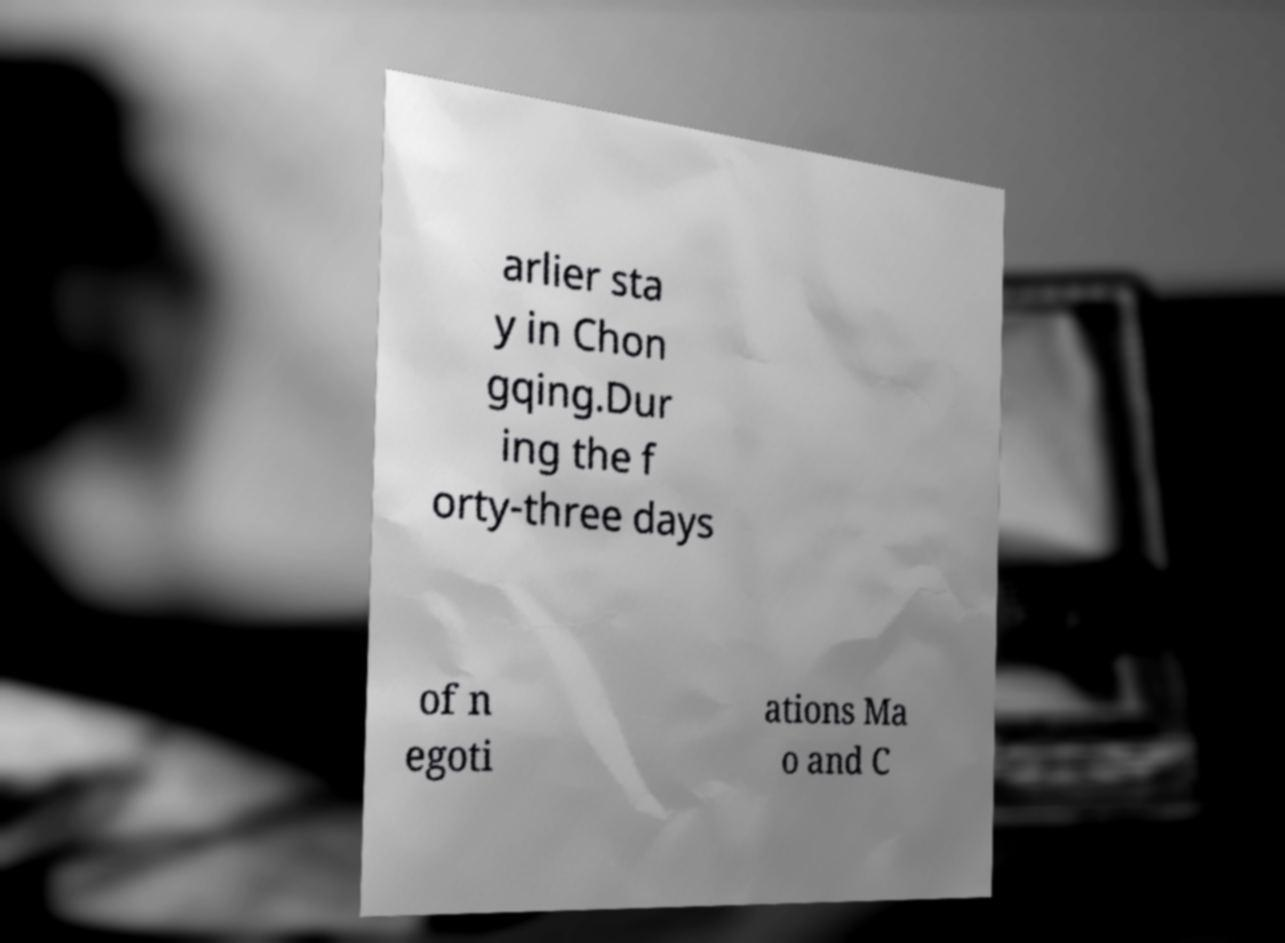Please read and relay the text visible in this image. What does it say? arlier sta y in Chon gqing.Dur ing the f orty-three days of n egoti ations Ma o and C 